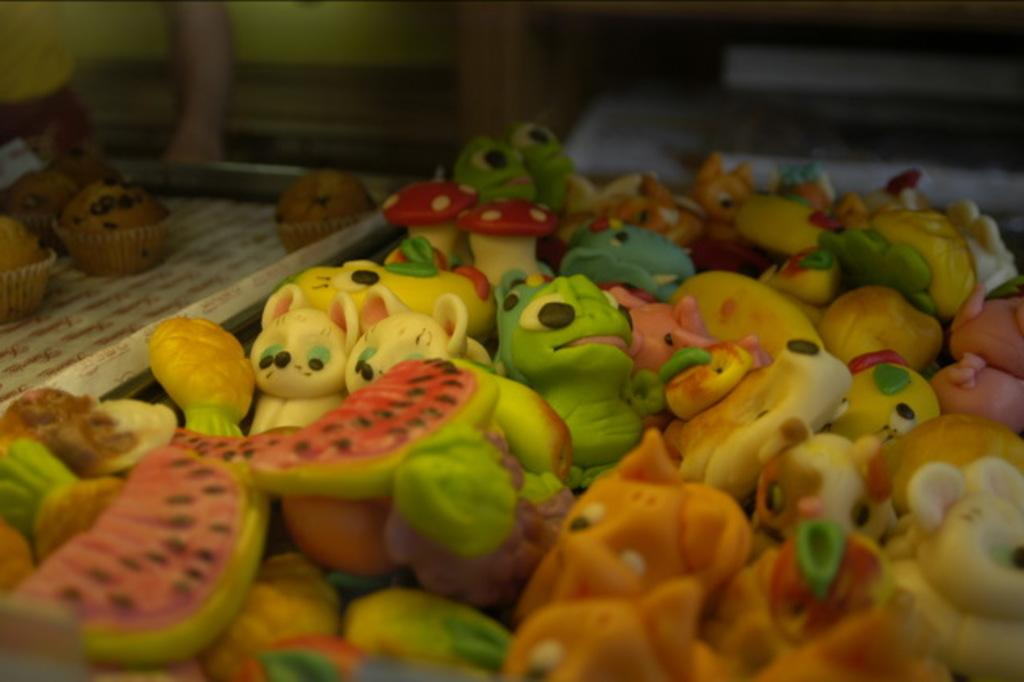What type of food items can be seen in the image? The food items in the image are in the shape of cartoons and other objects. Can you describe the location of the cupcakes in the image? The cupcakes are on the left side of the image. What type of dust can be seen on the food items in the image? There is no dust visible on the food items in the image. What type of flesh is present in the image? There is no flesh present in the image; it features food items in the shape of cartoons and other objects. 